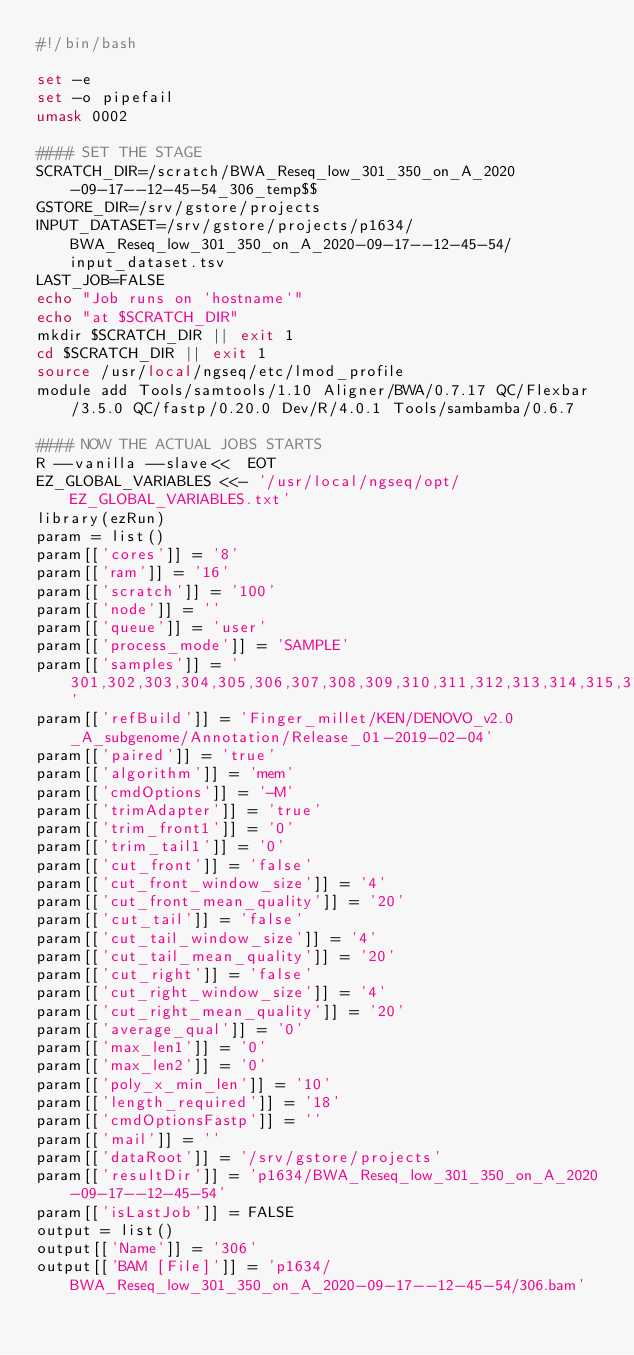<code> <loc_0><loc_0><loc_500><loc_500><_Bash_>#!/bin/bash

set -e
set -o pipefail
umask 0002

#### SET THE STAGE
SCRATCH_DIR=/scratch/BWA_Reseq_low_301_350_on_A_2020-09-17--12-45-54_306_temp$$
GSTORE_DIR=/srv/gstore/projects
INPUT_DATASET=/srv/gstore/projects/p1634/BWA_Reseq_low_301_350_on_A_2020-09-17--12-45-54/input_dataset.tsv
LAST_JOB=FALSE
echo "Job runs on `hostname`"
echo "at $SCRATCH_DIR"
mkdir $SCRATCH_DIR || exit 1
cd $SCRATCH_DIR || exit 1
source /usr/local/ngseq/etc/lmod_profile
module add Tools/samtools/1.10 Aligner/BWA/0.7.17 QC/Flexbar/3.5.0 QC/fastp/0.20.0 Dev/R/4.0.1 Tools/sambamba/0.6.7

#### NOW THE ACTUAL JOBS STARTS
R --vanilla --slave<<  EOT
EZ_GLOBAL_VARIABLES <<- '/usr/local/ngseq/opt/EZ_GLOBAL_VARIABLES.txt'
library(ezRun)
param = list()
param[['cores']] = '8'
param[['ram']] = '16'
param[['scratch']] = '100'
param[['node']] = ''
param[['queue']] = 'user'
param[['process_mode']] = 'SAMPLE'
param[['samples']] = '301,302,303,304,305,306,307,308,309,310,311,312,313,314,315,316,317,318,319,320,321,322,323,324,325,326,327,328,329,330,331,332,333,334,335,336,337,338,339,340,341,342,343,344,345,346,347,348,349,350'
param[['refBuild']] = 'Finger_millet/KEN/DENOVO_v2.0_A_subgenome/Annotation/Release_01-2019-02-04'
param[['paired']] = 'true'
param[['algorithm']] = 'mem'
param[['cmdOptions']] = '-M'
param[['trimAdapter']] = 'true'
param[['trim_front1']] = '0'
param[['trim_tail1']] = '0'
param[['cut_front']] = 'false'
param[['cut_front_window_size']] = '4'
param[['cut_front_mean_quality']] = '20'
param[['cut_tail']] = 'false'
param[['cut_tail_window_size']] = '4'
param[['cut_tail_mean_quality']] = '20'
param[['cut_right']] = 'false'
param[['cut_right_window_size']] = '4'
param[['cut_right_mean_quality']] = '20'
param[['average_qual']] = '0'
param[['max_len1']] = '0'
param[['max_len2']] = '0'
param[['poly_x_min_len']] = '10'
param[['length_required']] = '18'
param[['cmdOptionsFastp']] = ''
param[['mail']] = ''
param[['dataRoot']] = '/srv/gstore/projects'
param[['resultDir']] = 'p1634/BWA_Reseq_low_301_350_on_A_2020-09-17--12-45-54'
param[['isLastJob']] = FALSE
output = list()
output[['Name']] = '306'
output[['BAM [File]']] = 'p1634/BWA_Reseq_low_301_350_on_A_2020-09-17--12-45-54/306.bam'</code> 